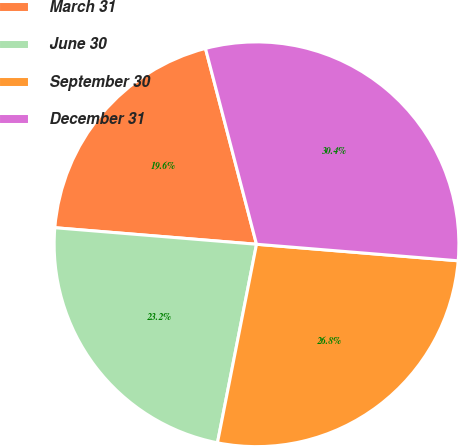Convert chart. <chart><loc_0><loc_0><loc_500><loc_500><pie_chart><fcel>March 31<fcel>June 30<fcel>September 30<fcel>December 31<nl><fcel>19.64%<fcel>23.21%<fcel>26.79%<fcel>30.36%<nl></chart> 